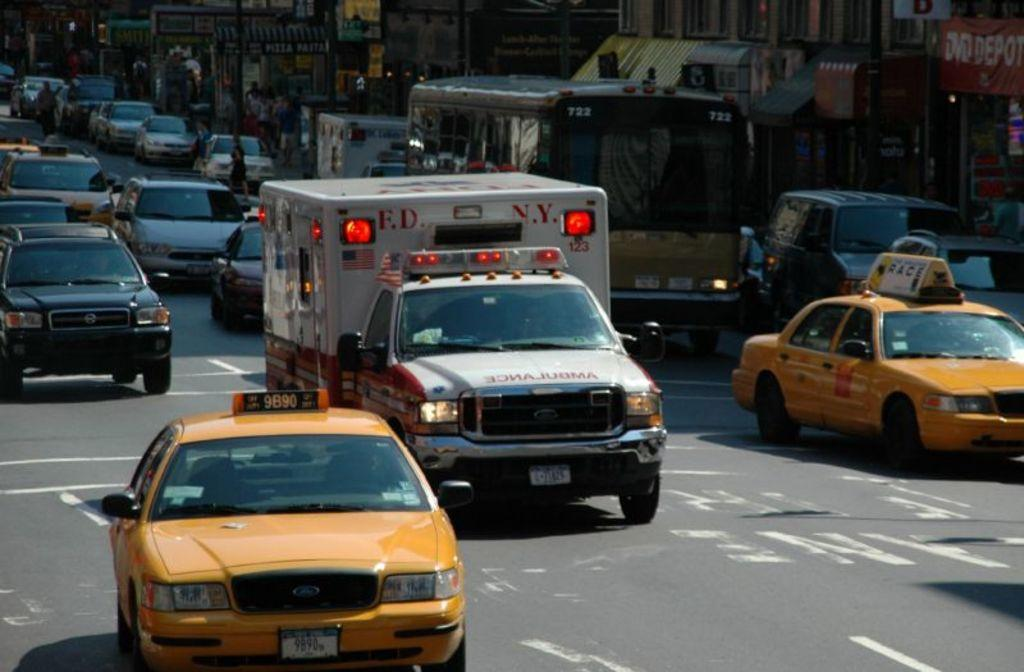<image>
Provide a brief description of the given image. An ambulance says ED and NY on the upper corners. 